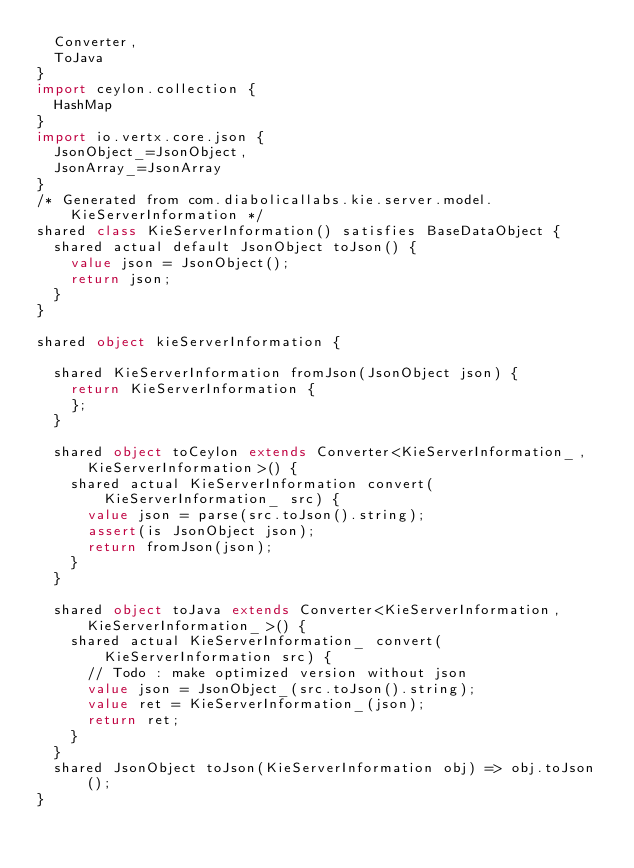Convert code to text. <code><loc_0><loc_0><loc_500><loc_500><_Ceylon_>  Converter,
  ToJava
}
import ceylon.collection {
  HashMap
}
import io.vertx.core.json {
  JsonObject_=JsonObject,
  JsonArray_=JsonArray
}
/* Generated from com.diabolicallabs.kie.server.model.KieServerInformation */
shared class KieServerInformation() satisfies BaseDataObject {
  shared actual default JsonObject toJson() {
    value json = JsonObject();
    return json;
  }
}

shared object kieServerInformation {

  shared KieServerInformation fromJson(JsonObject json) {
    return KieServerInformation {
    };
  }

  shared object toCeylon extends Converter<KieServerInformation_, KieServerInformation>() {
    shared actual KieServerInformation convert(KieServerInformation_ src) {
      value json = parse(src.toJson().string);
      assert(is JsonObject json);
      return fromJson(json);
    }
  }

  shared object toJava extends Converter<KieServerInformation, KieServerInformation_>() {
    shared actual KieServerInformation_ convert(KieServerInformation src) {
      // Todo : make optimized version without json
      value json = JsonObject_(src.toJson().string);
      value ret = KieServerInformation_(json);
      return ret;
    }
  }
  shared JsonObject toJson(KieServerInformation obj) => obj.toJson();
}
</code> 